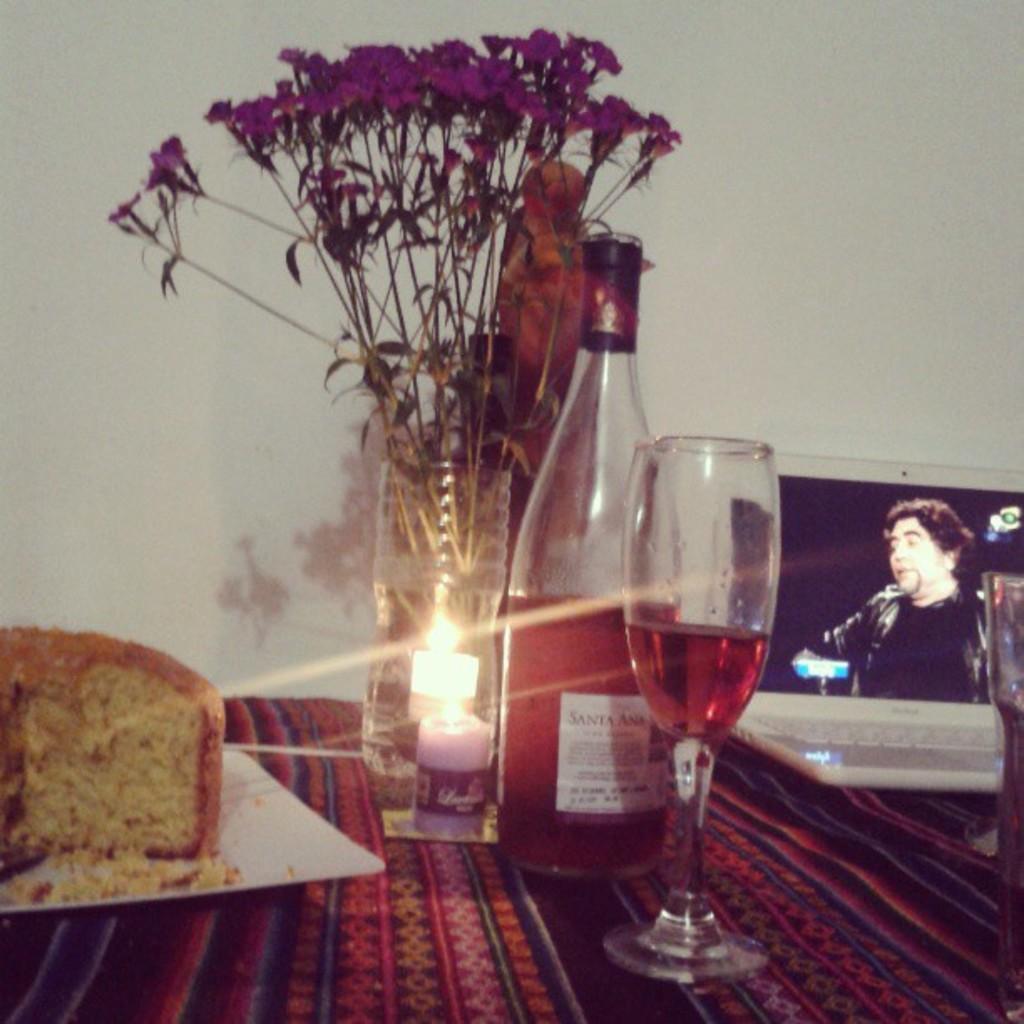Please provide a concise description of this image. In this image I can see a pink colored surface and on it I can see a white colored plate and on the plate I can see a cake which is brown and cream in color and I can see a candle, few flowers which are pink in color, a wine bottle and a wine glass. In the background I can see a laptop which is white in color and a white colored wall. 